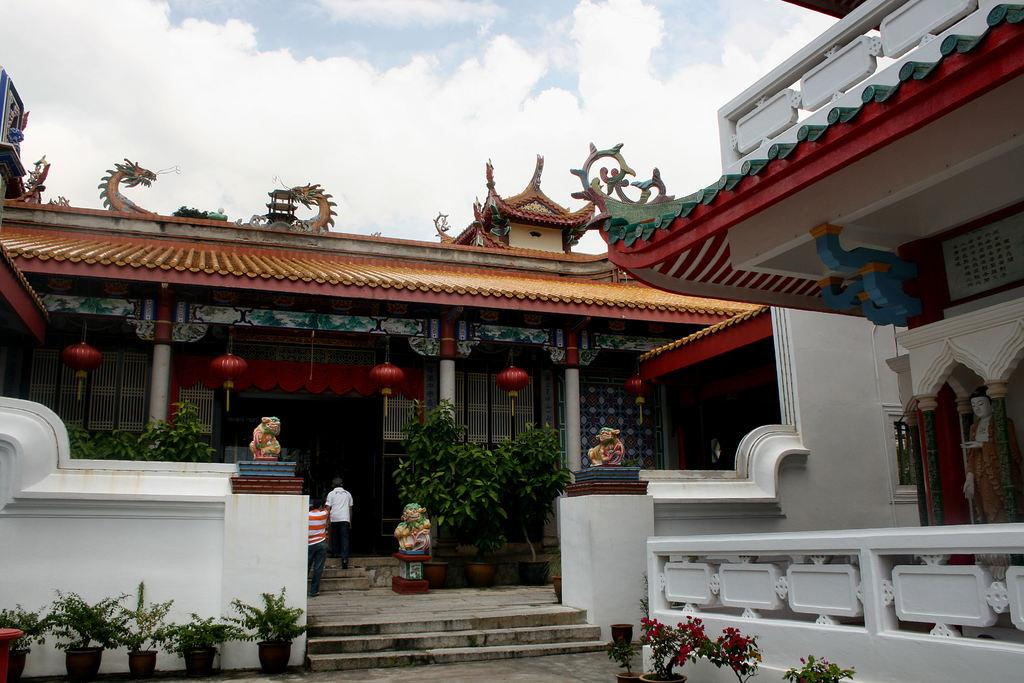What type of plants can be seen in the image? There are houseplants in the image. What type of structure is present in the image? There is a fence in the image. What type of decorative objects are in the image? There are statues in the image. How many people are in the image? There are two persons in the image. What type of man-made structures are visible in the image? There are buildings in the image. What part of the natural environment is visible in the image? The sky is visible at the top of the image. Can you determine the time of day the image was taken? The image was likely taken during the day, as the sky is visible and not dark. What type of legal advice is the lawyer providing to the ducks in the image? There is no lawyer or ducks present in the image, so it is not possible to answer that question. 